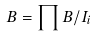<formula> <loc_0><loc_0><loc_500><loc_500>B = \prod B / I _ { i }</formula> 